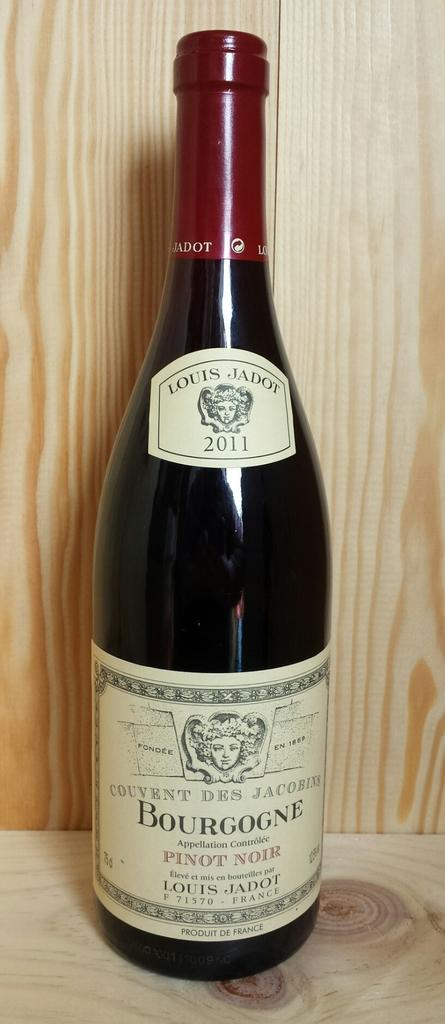Provide a one-sentence caption for the provided image. AN AMBER BOTTLE OF BOURGONE WINE BY LOUIS JADOT. 